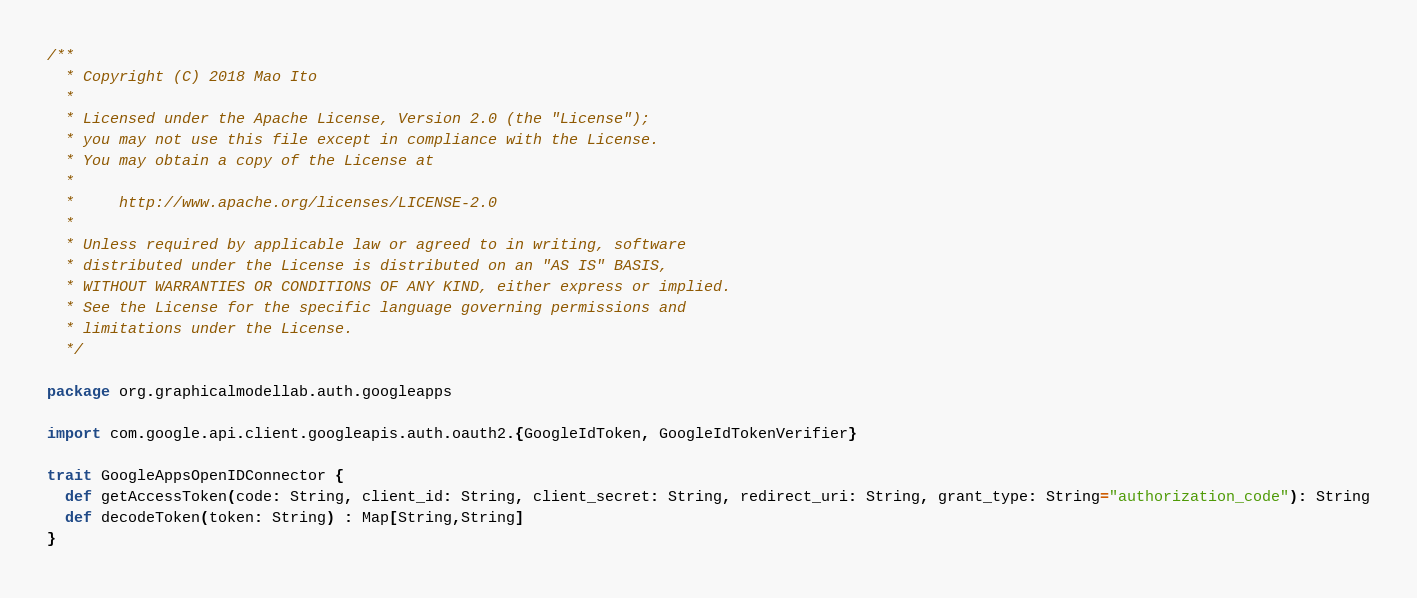Convert code to text. <code><loc_0><loc_0><loc_500><loc_500><_Scala_>/**
  * Copyright (C) 2018 Mao Ito
  *
  * Licensed under the Apache License, Version 2.0 (the "License");
  * you may not use this file except in compliance with the License.
  * You may obtain a copy of the License at
  *
  *     http://www.apache.org/licenses/LICENSE-2.0
  *
  * Unless required by applicable law or agreed to in writing, software
  * distributed under the License is distributed on an "AS IS" BASIS,
  * WITHOUT WARRANTIES OR CONDITIONS OF ANY KIND, either express or implied.
  * See the License for the specific language governing permissions and
  * limitations under the License.
  */

package org.graphicalmodellab.auth.googleapps

import com.google.api.client.googleapis.auth.oauth2.{GoogleIdToken, GoogleIdTokenVerifier}

trait GoogleAppsOpenIDConnector {
  def getAccessToken(code: String, client_id: String, client_secret: String, redirect_uri: String, grant_type: String="authorization_code"): String
  def decodeToken(token: String) : Map[String,String]
}
</code> 